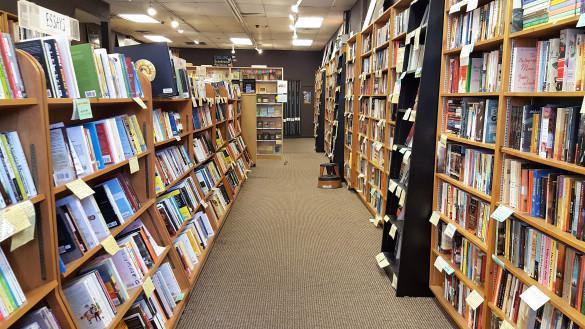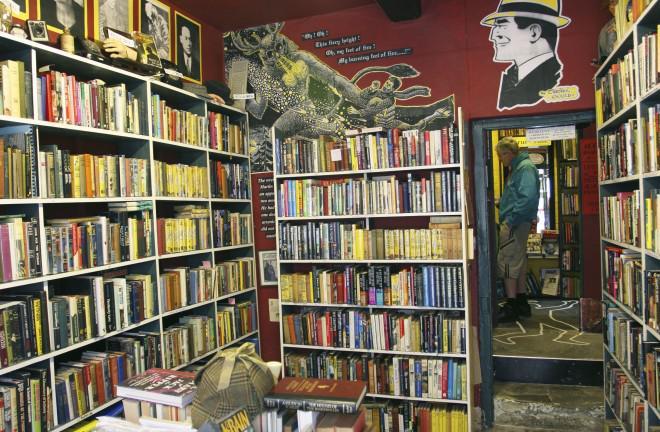The first image is the image on the left, the second image is the image on the right. For the images shown, is this caption "There is a person behind the counter of a bookstore that has at least four separate bookshelves." true? Answer yes or no. No. The first image is the image on the left, the second image is the image on the right. For the images displayed, is the sentence "People are seen enjoying books in a bookstore." factually correct? Answer yes or no. No. 